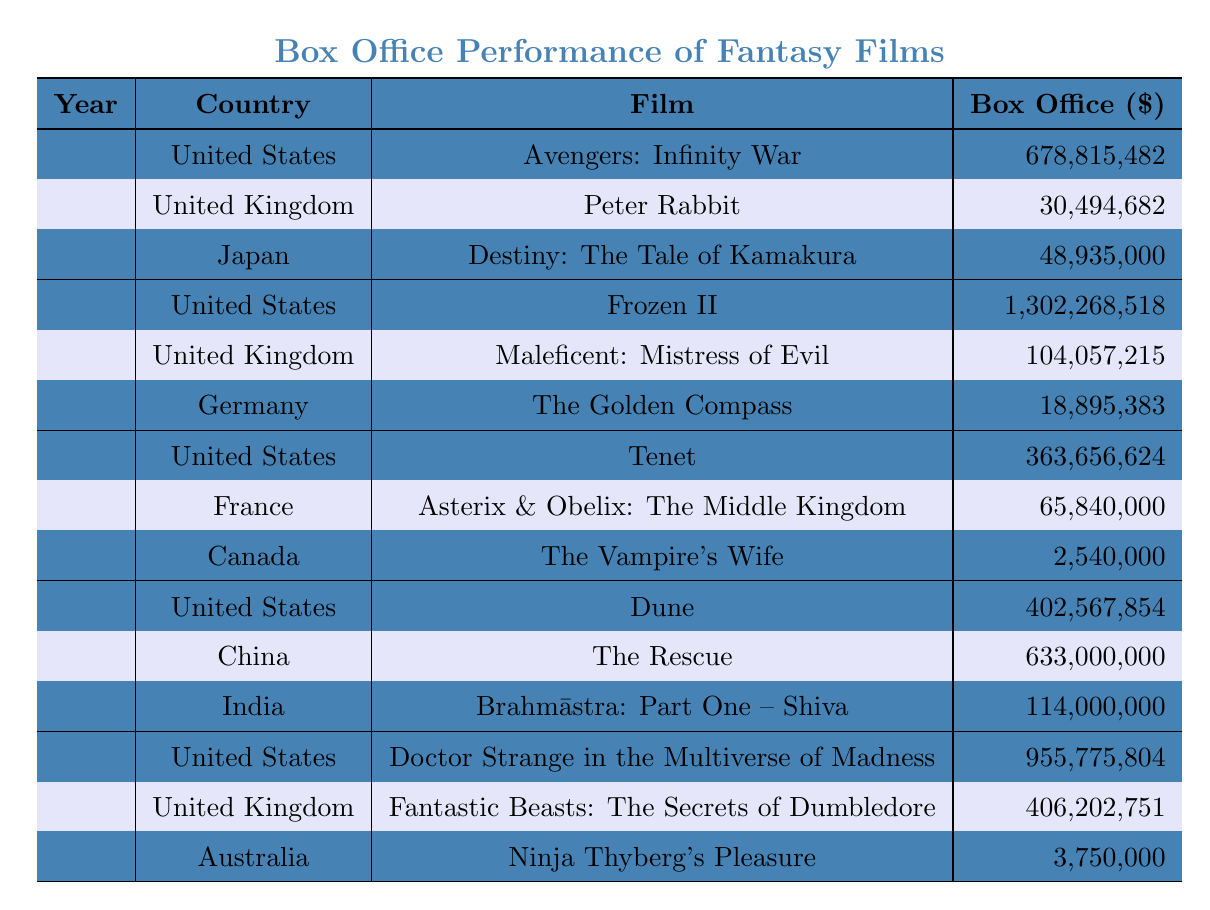What's the highest box office gross for a fantasy film in 2019? The table shows that "Frozen II" in the United States grossed 1,302,268,518, which is higher than all other films listed for 2019.
Answer: 1,302,268,518 Which country had the lowest box office gross for a fantasy film in 2020? The table shows "The Vampire's Wife" from Canada grossed 2,540,000, which is lower than "Tenet" (United States) and "Asterix & Obelix: The Middle Kingdom" (France).
Answer: 2,540,000 What is the total box office gross of fantasy films from the United States across all listed years? The totals for the United States are 678,815,482 (2018) + 1,302,268,518 (2019) + 363,656,624 (2020) + 402,567,854 (2021) + 955,775,804 (2022), resulting in a total of 3,702,150,282.
Answer: 3,702,150,282 Which film had the highest box office gross in 2021? In 2021, "The Rescue" from China grossed 633,000,000, which is higher than "Dune" from the United States and "Brahmāstra: Part One – Shiva" from India.
Answer: The Rescue Was there any fantasy film released in Germany during the years shown? Yes, the table indicates that "The Golden Compass" was released in Germany in 2019.
Answer: Yes How much more did "Doctor Strange in the Multiverse of Madness" earn compared to "Fantastic Beasts: The Secrets of Dumbledore"? The box office for "Doctor Strange" is 955,775,804 and for "Fantastic Beasts" is 406,202,751. The difference is 955,775,804 - 406,202,751 = 549,573,053.
Answer: 549,573,053 What percentage of the total box office gross for 2018 comes from the United States? The total gross for 2018 is 678,815,482 (US) + 30,494,682 (UK) + 48,935,000 (Japan) = 758,343,164. The US portion is 678,815,482, which is (678,815,482 / 758,343,164) * 100 = approximately 89.5%.
Answer: 89.5% Which year had the highest total box office gross across all countries, and what was that total? Adding up the box office grosses for all countries for each year: 2018 = 758,343,164, 2019 = 1,415,649,116, 2020 = 431,470,624, 2021 = 1,149,567,854, 2022 = 1,365,979,555. 2019 has the highest total at 1,415,649,116.
Answer: 1,415,649,116 How many countries are represented in the 2022 box office data? The table shows three entries for 2022: United States, United Kingdom, and Australia. Thus, there are three countries represented.
Answer: 3 Is there a film that grossed below 10 million in the provided data? Yes, "The Vampire's Wife" from Canada in 2020 grossed 2,540,000, which is below 10 million.
Answer: Yes 